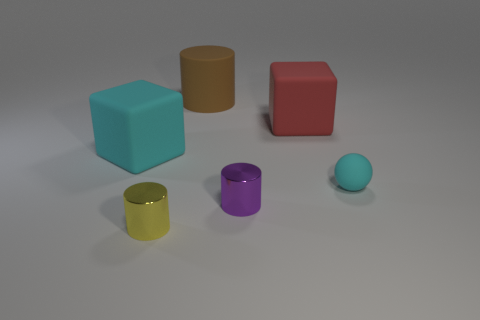Add 1 small yellow things. How many objects exist? 7 Subtract all spheres. How many objects are left? 5 Add 5 rubber cubes. How many rubber cubes exist? 7 Subtract 0 brown balls. How many objects are left? 6 Subtract all yellow cylinders. Subtract all yellow shiny objects. How many objects are left? 4 Add 1 big cyan rubber things. How many big cyan rubber things are left? 2 